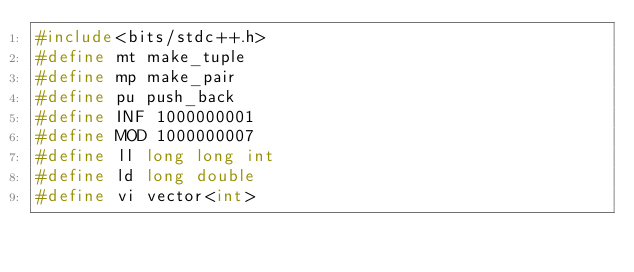<code> <loc_0><loc_0><loc_500><loc_500><_C++_>#include<bits/stdc++.h>
#define mt make_tuple
#define mp make_pair
#define pu push_back
#define INF 1000000001
#define MOD 1000000007
#define ll long long int
#define ld long double
#define vi vector<int></code> 